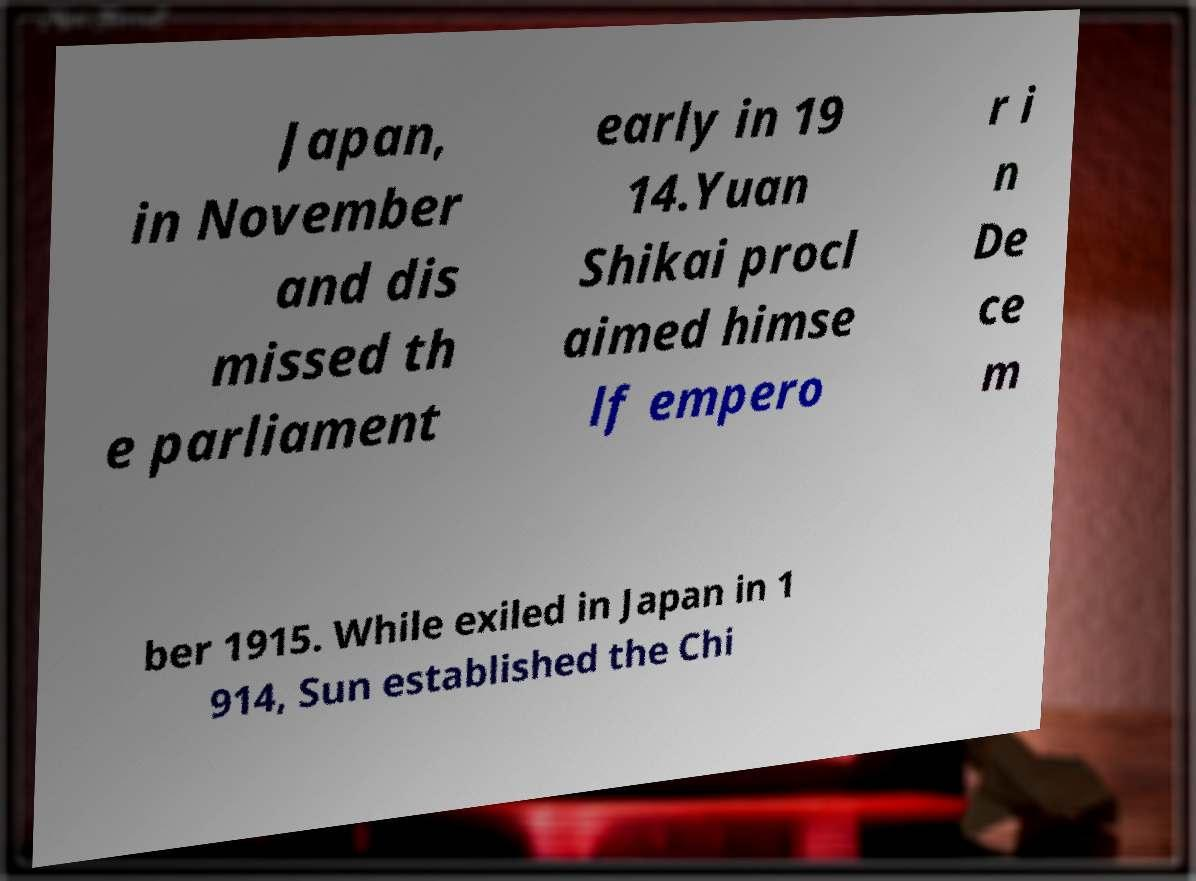Please read and relay the text visible in this image. What does it say? Japan, in November and dis missed th e parliament early in 19 14.Yuan Shikai procl aimed himse lf empero r i n De ce m ber 1915. While exiled in Japan in 1 914, Sun established the Chi 